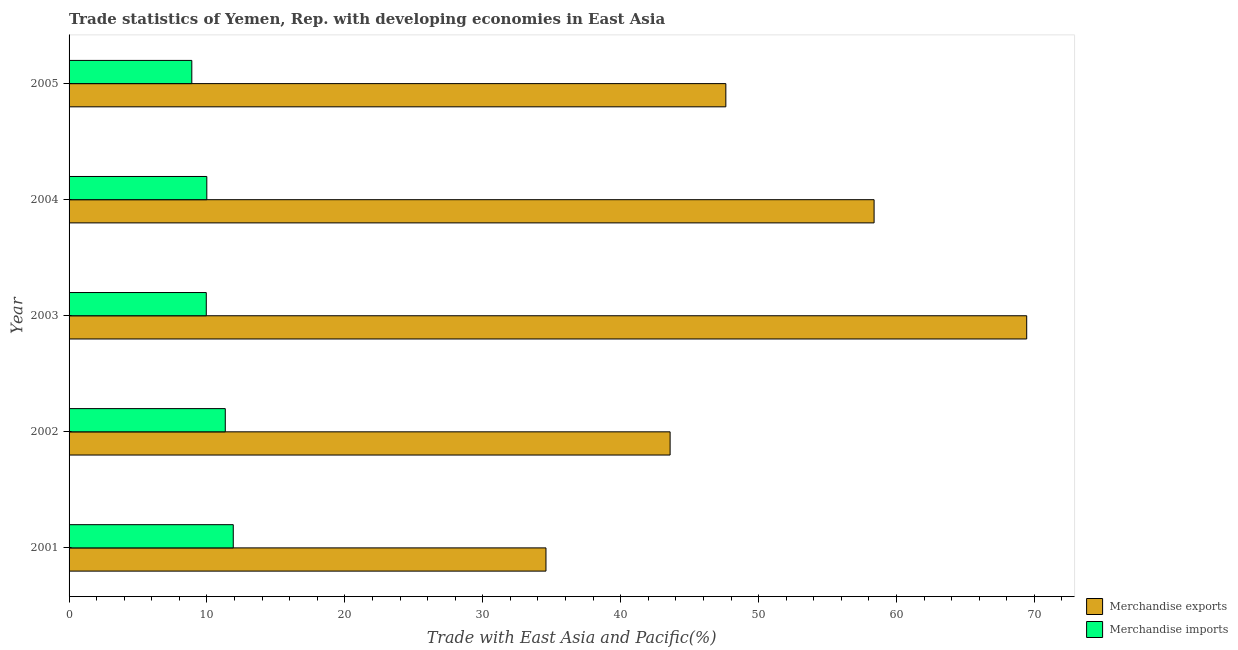How many groups of bars are there?
Keep it short and to the point. 5. Are the number of bars per tick equal to the number of legend labels?
Offer a very short reply. Yes. How many bars are there on the 4th tick from the bottom?
Your answer should be very brief. 2. What is the label of the 4th group of bars from the top?
Your response must be concise. 2002. What is the merchandise exports in 2004?
Your answer should be very brief. 58.38. Across all years, what is the maximum merchandise imports?
Keep it short and to the point. 11.91. Across all years, what is the minimum merchandise imports?
Offer a very short reply. 8.9. What is the total merchandise imports in the graph?
Give a very brief answer. 52.07. What is the difference between the merchandise imports in 2001 and that in 2003?
Ensure brevity in your answer.  1.96. What is the difference between the merchandise exports in 2002 and the merchandise imports in 2003?
Offer a very short reply. 33.63. What is the average merchandise exports per year?
Your answer should be compact. 50.72. In the year 2005, what is the difference between the merchandise imports and merchandise exports?
Provide a succinct answer. -38.73. What is the ratio of the merchandise exports in 2001 to that in 2003?
Offer a very short reply. 0.5. What is the difference between the highest and the second highest merchandise imports?
Give a very brief answer. 0.58. What is the difference between the highest and the lowest merchandise exports?
Your answer should be compact. 34.86. Is the sum of the merchandise exports in 2001 and 2002 greater than the maximum merchandise imports across all years?
Make the answer very short. Yes. What does the 2nd bar from the top in 2003 represents?
Offer a terse response. Merchandise exports. How many bars are there?
Make the answer very short. 10. Are all the bars in the graph horizontal?
Make the answer very short. Yes. How many years are there in the graph?
Your answer should be compact. 5. What is the difference between two consecutive major ticks on the X-axis?
Provide a succinct answer. 10. How many legend labels are there?
Give a very brief answer. 2. What is the title of the graph?
Your answer should be compact. Trade statistics of Yemen, Rep. with developing economies in East Asia. Does "Age 65(female)" appear as one of the legend labels in the graph?
Your answer should be compact. No. What is the label or title of the X-axis?
Ensure brevity in your answer.  Trade with East Asia and Pacific(%). What is the label or title of the Y-axis?
Give a very brief answer. Year. What is the Trade with East Asia and Pacific(%) of Merchandise exports in 2001?
Ensure brevity in your answer.  34.58. What is the Trade with East Asia and Pacific(%) in Merchandise imports in 2001?
Give a very brief answer. 11.91. What is the Trade with East Asia and Pacific(%) in Merchandise exports in 2002?
Provide a succinct answer. 43.58. What is the Trade with East Asia and Pacific(%) in Merchandise imports in 2002?
Make the answer very short. 11.33. What is the Trade with East Asia and Pacific(%) in Merchandise exports in 2003?
Offer a terse response. 69.44. What is the Trade with East Asia and Pacific(%) in Merchandise imports in 2003?
Your answer should be compact. 9.95. What is the Trade with East Asia and Pacific(%) in Merchandise exports in 2004?
Give a very brief answer. 58.38. What is the Trade with East Asia and Pacific(%) in Merchandise imports in 2004?
Your response must be concise. 9.99. What is the Trade with East Asia and Pacific(%) in Merchandise exports in 2005?
Offer a terse response. 47.63. What is the Trade with East Asia and Pacific(%) of Merchandise imports in 2005?
Your answer should be compact. 8.9. Across all years, what is the maximum Trade with East Asia and Pacific(%) of Merchandise exports?
Your response must be concise. 69.44. Across all years, what is the maximum Trade with East Asia and Pacific(%) of Merchandise imports?
Your answer should be compact. 11.91. Across all years, what is the minimum Trade with East Asia and Pacific(%) in Merchandise exports?
Your answer should be compact. 34.58. Across all years, what is the minimum Trade with East Asia and Pacific(%) in Merchandise imports?
Keep it short and to the point. 8.9. What is the total Trade with East Asia and Pacific(%) in Merchandise exports in the graph?
Offer a terse response. 253.61. What is the total Trade with East Asia and Pacific(%) in Merchandise imports in the graph?
Keep it short and to the point. 52.07. What is the difference between the Trade with East Asia and Pacific(%) in Merchandise exports in 2001 and that in 2002?
Offer a very short reply. -9. What is the difference between the Trade with East Asia and Pacific(%) of Merchandise imports in 2001 and that in 2002?
Make the answer very short. 0.58. What is the difference between the Trade with East Asia and Pacific(%) in Merchandise exports in 2001 and that in 2003?
Provide a succinct answer. -34.86. What is the difference between the Trade with East Asia and Pacific(%) of Merchandise imports in 2001 and that in 2003?
Make the answer very short. 1.96. What is the difference between the Trade with East Asia and Pacific(%) of Merchandise exports in 2001 and that in 2004?
Provide a short and direct response. -23.79. What is the difference between the Trade with East Asia and Pacific(%) of Merchandise imports in 2001 and that in 2004?
Your response must be concise. 1.92. What is the difference between the Trade with East Asia and Pacific(%) of Merchandise exports in 2001 and that in 2005?
Offer a terse response. -13.04. What is the difference between the Trade with East Asia and Pacific(%) in Merchandise imports in 2001 and that in 2005?
Offer a terse response. 3.01. What is the difference between the Trade with East Asia and Pacific(%) in Merchandise exports in 2002 and that in 2003?
Your response must be concise. -25.86. What is the difference between the Trade with East Asia and Pacific(%) in Merchandise imports in 2002 and that in 2003?
Offer a very short reply. 1.38. What is the difference between the Trade with East Asia and Pacific(%) of Merchandise exports in 2002 and that in 2004?
Provide a succinct answer. -14.79. What is the difference between the Trade with East Asia and Pacific(%) of Merchandise imports in 2002 and that in 2004?
Provide a short and direct response. 1.34. What is the difference between the Trade with East Asia and Pacific(%) in Merchandise exports in 2002 and that in 2005?
Provide a succinct answer. -4.04. What is the difference between the Trade with East Asia and Pacific(%) in Merchandise imports in 2002 and that in 2005?
Offer a terse response. 2.43. What is the difference between the Trade with East Asia and Pacific(%) in Merchandise exports in 2003 and that in 2004?
Your answer should be compact. 11.07. What is the difference between the Trade with East Asia and Pacific(%) in Merchandise imports in 2003 and that in 2004?
Provide a short and direct response. -0.04. What is the difference between the Trade with East Asia and Pacific(%) of Merchandise exports in 2003 and that in 2005?
Offer a terse response. 21.82. What is the difference between the Trade with East Asia and Pacific(%) of Merchandise imports in 2003 and that in 2005?
Give a very brief answer. 1.05. What is the difference between the Trade with East Asia and Pacific(%) of Merchandise exports in 2004 and that in 2005?
Your answer should be very brief. 10.75. What is the difference between the Trade with East Asia and Pacific(%) in Merchandise imports in 2004 and that in 2005?
Keep it short and to the point. 1.09. What is the difference between the Trade with East Asia and Pacific(%) of Merchandise exports in 2001 and the Trade with East Asia and Pacific(%) of Merchandise imports in 2002?
Offer a terse response. 23.25. What is the difference between the Trade with East Asia and Pacific(%) in Merchandise exports in 2001 and the Trade with East Asia and Pacific(%) in Merchandise imports in 2003?
Ensure brevity in your answer.  24.63. What is the difference between the Trade with East Asia and Pacific(%) in Merchandise exports in 2001 and the Trade with East Asia and Pacific(%) in Merchandise imports in 2004?
Your answer should be very brief. 24.59. What is the difference between the Trade with East Asia and Pacific(%) of Merchandise exports in 2001 and the Trade with East Asia and Pacific(%) of Merchandise imports in 2005?
Your answer should be compact. 25.68. What is the difference between the Trade with East Asia and Pacific(%) of Merchandise exports in 2002 and the Trade with East Asia and Pacific(%) of Merchandise imports in 2003?
Provide a succinct answer. 33.63. What is the difference between the Trade with East Asia and Pacific(%) in Merchandise exports in 2002 and the Trade with East Asia and Pacific(%) in Merchandise imports in 2004?
Keep it short and to the point. 33.6. What is the difference between the Trade with East Asia and Pacific(%) of Merchandise exports in 2002 and the Trade with East Asia and Pacific(%) of Merchandise imports in 2005?
Provide a short and direct response. 34.68. What is the difference between the Trade with East Asia and Pacific(%) in Merchandise exports in 2003 and the Trade with East Asia and Pacific(%) in Merchandise imports in 2004?
Your answer should be very brief. 59.46. What is the difference between the Trade with East Asia and Pacific(%) in Merchandise exports in 2003 and the Trade with East Asia and Pacific(%) in Merchandise imports in 2005?
Offer a terse response. 60.54. What is the difference between the Trade with East Asia and Pacific(%) in Merchandise exports in 2004 and the Trade with East Asia and Pacific(%) in Merchandise imports in 2005?
Make the answer very short. 49.48. What is the average Trade with East Asia and Pacific(%) in Merchandise exports per year?
Provide a short and direct response. 50.72. What is the average Trade with East Asia and Pacific(%) in Merchandise imports per year?
Your answer should be compact. 10.41. In the year 2001, what is the difference between the Trade with East Asia and Pacific(%) in Merchandise exports and Trade with East Asia and Pacific(%) in Merchandise imports?
Make the answer very short. 22.68. In the year 2002, what is the difference between the Trade with East Asia and Pacific(%) in Merchandise exports and Trade with East Asia and Pacific(%) in Merchandise imports?
Your answer should be compact. 32.26. In the year 2003, what is the difference between the Trade with East Asia and Pacific(%) of Merchandise exports and Trade with East Asia and Pacific(%) of Merchandise imports?
Make the answer very short. 59.49. In the year 2004, what is the difference between the Trade with East Asia and Pacific(%) of Merchandise exports and Trade with East Asia and Pacific(%) of Merchandise imports?
Offer a terse response. 48.39. In the year 2005, what is the difference between the Trade with East Asia and Pacific(%) in Merchandise exports and Trade with East Asia and Pacific(%) in Merchandise imports?
Your answer should be very brief. 38.73. What is the ratio of the Trade with East Asia and Pacific(%) of Merchandise exports in 2001 to that in 2002?
Keep it short and to the point. 0.79. What is the ratio of the Trade with East Asia and Pacific(%) of Merchandise imports in 2001 to that in 2002?
Provide a succinct answer. 1.05. What is the ratio of the Trade with East Asia and Pacific(%) in Merchandise exports in 2001 to that in 2003?
Give a very brief answer. 0.5. What is the ratio of the Trade with East Asia and Pacific(%) in Merchandise imports in 2001 to that in 2003?
Your response must be concise. 1.2. What is the ratio of the Trade with East Asia and Pacific(%) of Merchandise exports in 2001 to that in 2004?
Make the answer very short. 0.59. What is the ratio of the Trade with East Asia and Pacific(%) of Merchandise imports in 2001 to that in 2004?
Offer a very short reply. 1.19. What is the ratio of the Trade with East Asia and Pacific(%) in Merchandise exports in 2001 to that in 2005?
Make the answer very short. 0.73. What is the ratio of the Trade with East Asia and Pacific(%) of Merchandise imports in 2001 to that in 2005?
Offer a very short reply. 1.34. What is the ratio of the Trade with East Asia and Pacific(%) in Merchandise exports in 2002 to that in 2003?
Offer a terse response. 0.63. What is the ratio of the Trade with East Asia and Pacific(%) of Merchandise imports in 2002 to that in 2003?
Offer a terse response. 1.14. What is the ratio of the Trade with East Asia and Pacific(%) in Merchandise exports in 2002 to that in 2004?
Provide a short and direct response. 0.75. What is the ratio of the Trade with East Asia and Pacific(%) in Merchandise imports in 2002 to that in 2004?
Keep it short and to the point. 1.13. What is the ratio of the Trade with East Asia and Pacific(%) in Merchandise exports in 2002 to that in 2005?
Provide a short and direct response. 0.92. What is the ratio of the Trade with East Asia and Pacific(%) of Merchandise imports in 2002 to that in 2005?
Your answer should be very brief. 1.27. What is the ratio of the Trade with East Asia and Pacific(%) of Merchandise exports in 2003 to that in 2004?
Ensure brevity in your answer.  1.19. What is the ratio of the Trade with East Asia and Pacific(%) of Merchandise imports in 2003 to that in 2004?
Ensure brevity in your answer.  1. What is the ratio of the Trade with East Asia and Pacific(%) in Merchandise exports in 2003 to that in 2005?
Provide a succinct answer. 1.46. What is the ratio of the Trade with East Asia and Pacific(%) in Merchandise imports in 2003 to that in 2005?
Ensure brevity in your answer.  1.12. What is the ratio of the Trade with East Asia and Pacific(%) of Merchandise exports in 2004 to that in 2005?
Provide a short and direct response. 1.23. What is the ratio of the Trade with East Asia and Pacific(%) in Merchandise imports in 2004 to that in 2005?
Ensure brevity in your answer.  1.12. What is the difference between the highest and the second highest Trade with East Asia and Pacific(%) in Merchandise exports?
Provide a succinct answer. 11.07. What is the difference between the highest and the second highest Trade with East Asia and Pacific(%) in Merchandise imports?
Ensure brevity in your answer.  0.58. What is the difference between the highest and the lowest Trade with East Asia and Pacific(%) of Merchandise exports?
Give a very brief answer. 34.86. What is the difference between the highest and the lowest Trade with East Asia and Pacific(%) of Merchandise imports?
Your answer should be compact. 3.01. 